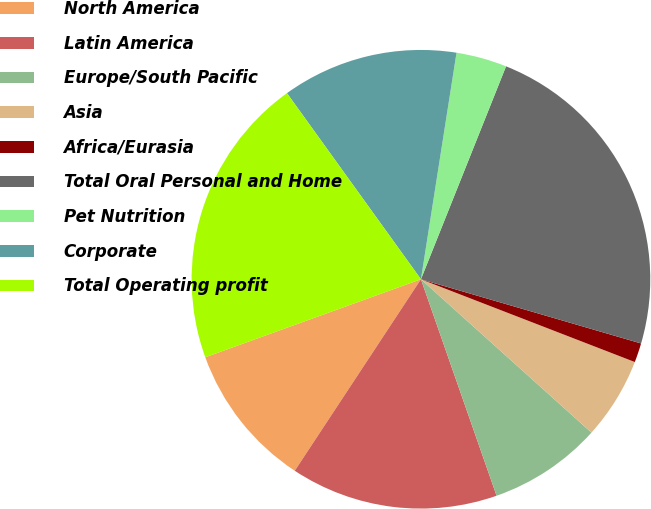Convert chart. <chart><loc_0><loc_0><loc_500><loc_500><pie_chart><fcel>North America<fcel>Latin America<fcel>Europe/South Pacific<fcel>Asia<fcel>Africa/Eurasia<fcel>Total Oral Personal and Home<fcel>Pet Nutrition<fcel>Corporate<fcel>Total Operating profit<nl><fcel>10.2%<fcel>14.62%<fcel>7.99%<fcel>5.78%<fcel>1.36%<fcel>23.46%<fcel>3.57%<fcel>12.41%<fcel>20.59%<nl></chart> 